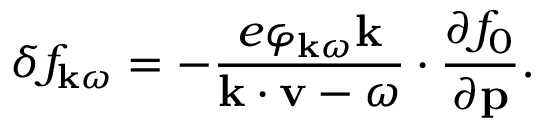<formula> <loc_0><loc_0><loc_500><loc_500>\delta f _ { { k } \omega } = - \frac { e \varphi _ { { k } \omega } { k } } { { k } \cdot { v } - \omega } \cdot \frac { \partial f _ { 0 } } { \partial p } .</formula> 